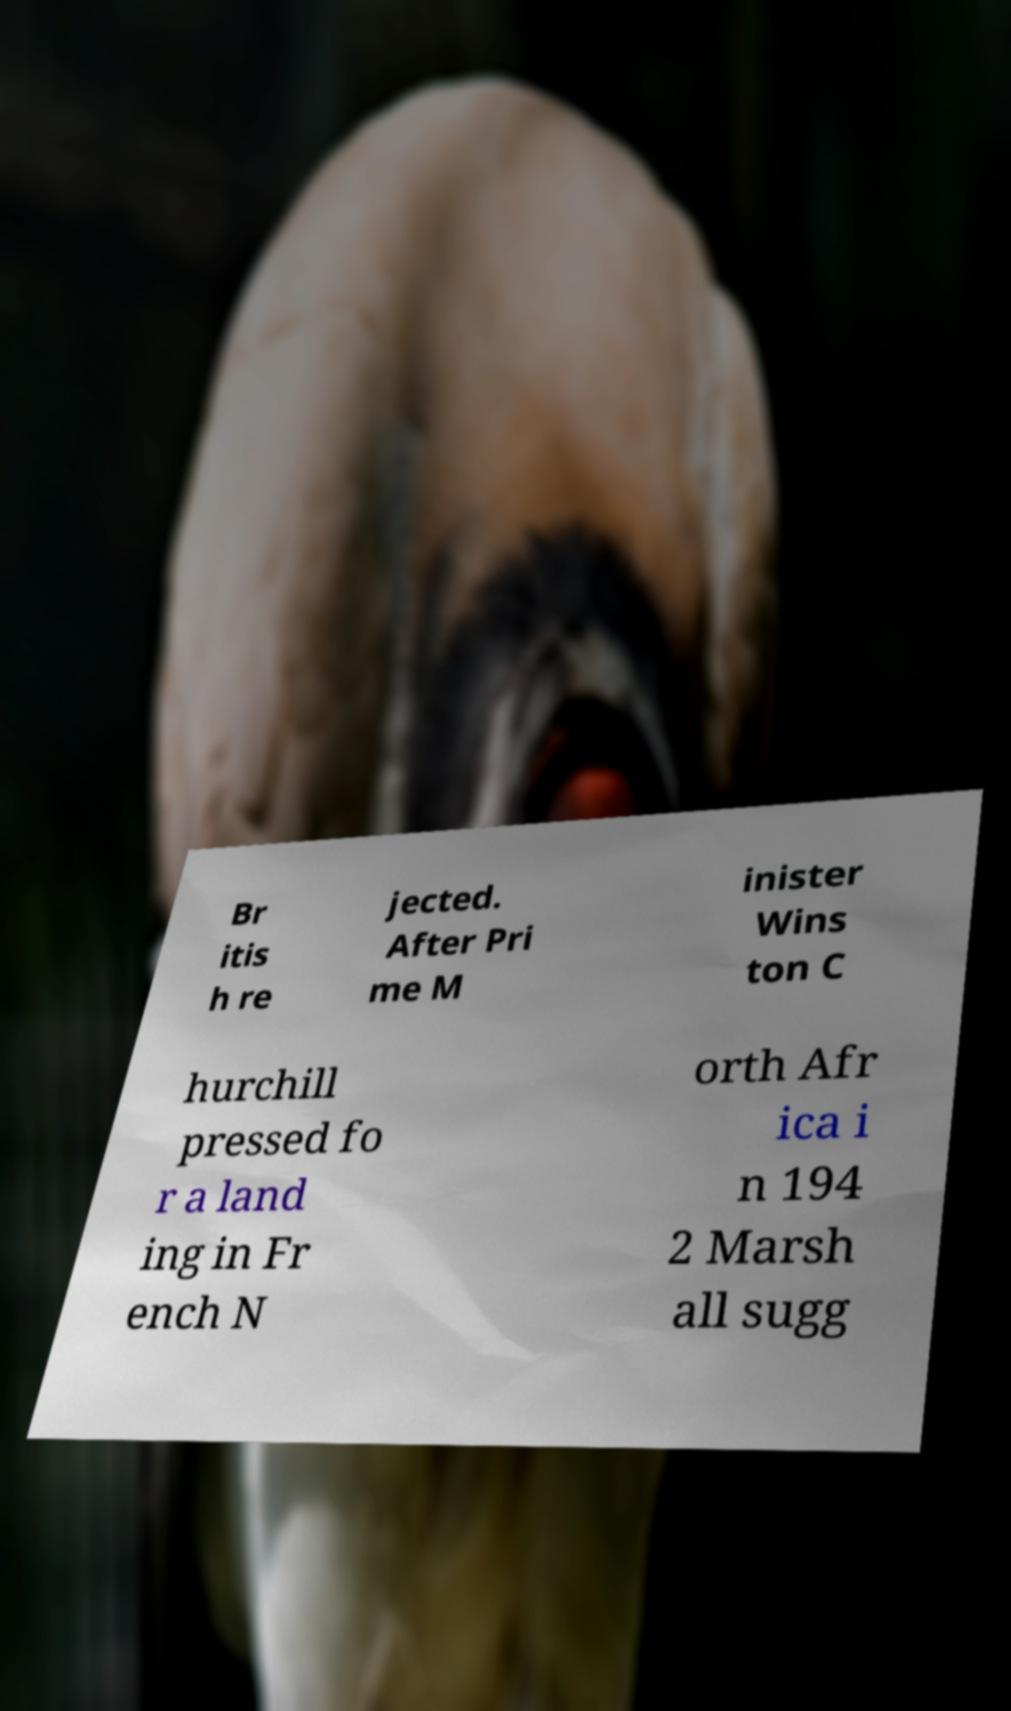Please read and relay the text visible in this image. What does it say? Br itis h re jected. After Pri me M inister Wins ton C hurchill pressed fo r a land ing in Fr ench N orth Afr ica i n 194 2 Marsh all sugg 